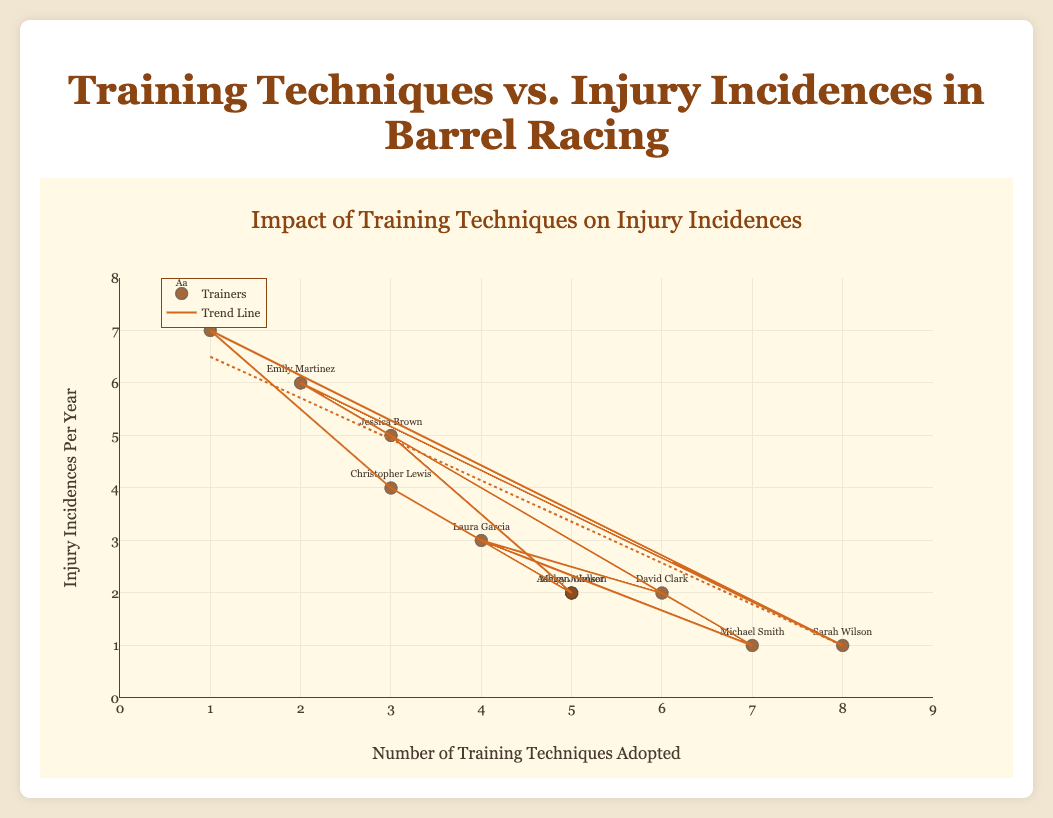What does the title of the plot indicate? The title of the plot is "Impact of Training Techniques on Injury Incidences," which suggests that the plot examines the relationship between the number of training techniques adopted by barrel racing trainers and the number of injury incidences per year.
Answer: Impact of Training Techniques on Injury Incidences How many trainers are represented in the plot? There are 10 data points, each representing a different trainer.
Answer: 10 For which trainer are the highest number of training techniques adopted, and how many injuries occurred? Sarah Wilson has adopted the highest number of training techniques (8) and her horses experienced 1 injury incidence per year.
Answer: Sarah Wilson, 1 Which trainer has the highest number of injury incidences per year, and how many training techniques have they adopted? Daniel Harris has the highest number of injury incidences per year (7) and has adopted 1 training technique.
Answer: Daniel Harris, 1 What trend is suggested by the trend line in the plot? The trend line shows a downward slope, suggesting that as the number of training techniques adopted increases, the number of injury incidences per year tends to decrease.
Answer: As techniques increase, injuries decrease What is the average number of training techniques adopted by all trainers? Sum the number of training techniques adopted by all trainers (5 + 3 + 7 + 4 + 6 + 2 + 8 + 1 + 3 + 5 = 44) and divide by the number of trainers (10). The average is 44/10.
Answer: 4.4 Compare the injury incidences per year of trainers who have adopted 3 techniques. What can be observed? Jessica Brown (5 injuries), Christopher Lewis (4 injuries). The number of injuries per year varies but tends to be higher among trainers who have adopted 3 techniques.
Answer: Varies, but higher incidences How many trainers have exactly 2 injury incidences per year and what are their names? There are three trainers with exactly 2 injury incidences per year: Ashley Johnson, David Clark, and Megan Walker.
Answer: Three trainers: Ashley Johnson, David Clark, Megan Walker Which trainers fall exactly on the trend line and how many techniques have they adopted? Trainers who fall exactly on the trend line have values that correspond with the line's equation. The closest trainer to the trend line with 1 injury and adopting 7 and 8 techniques are Michael Smith and Sarah Wilson.
Answer: Michael Smith, Sarah Wilson 